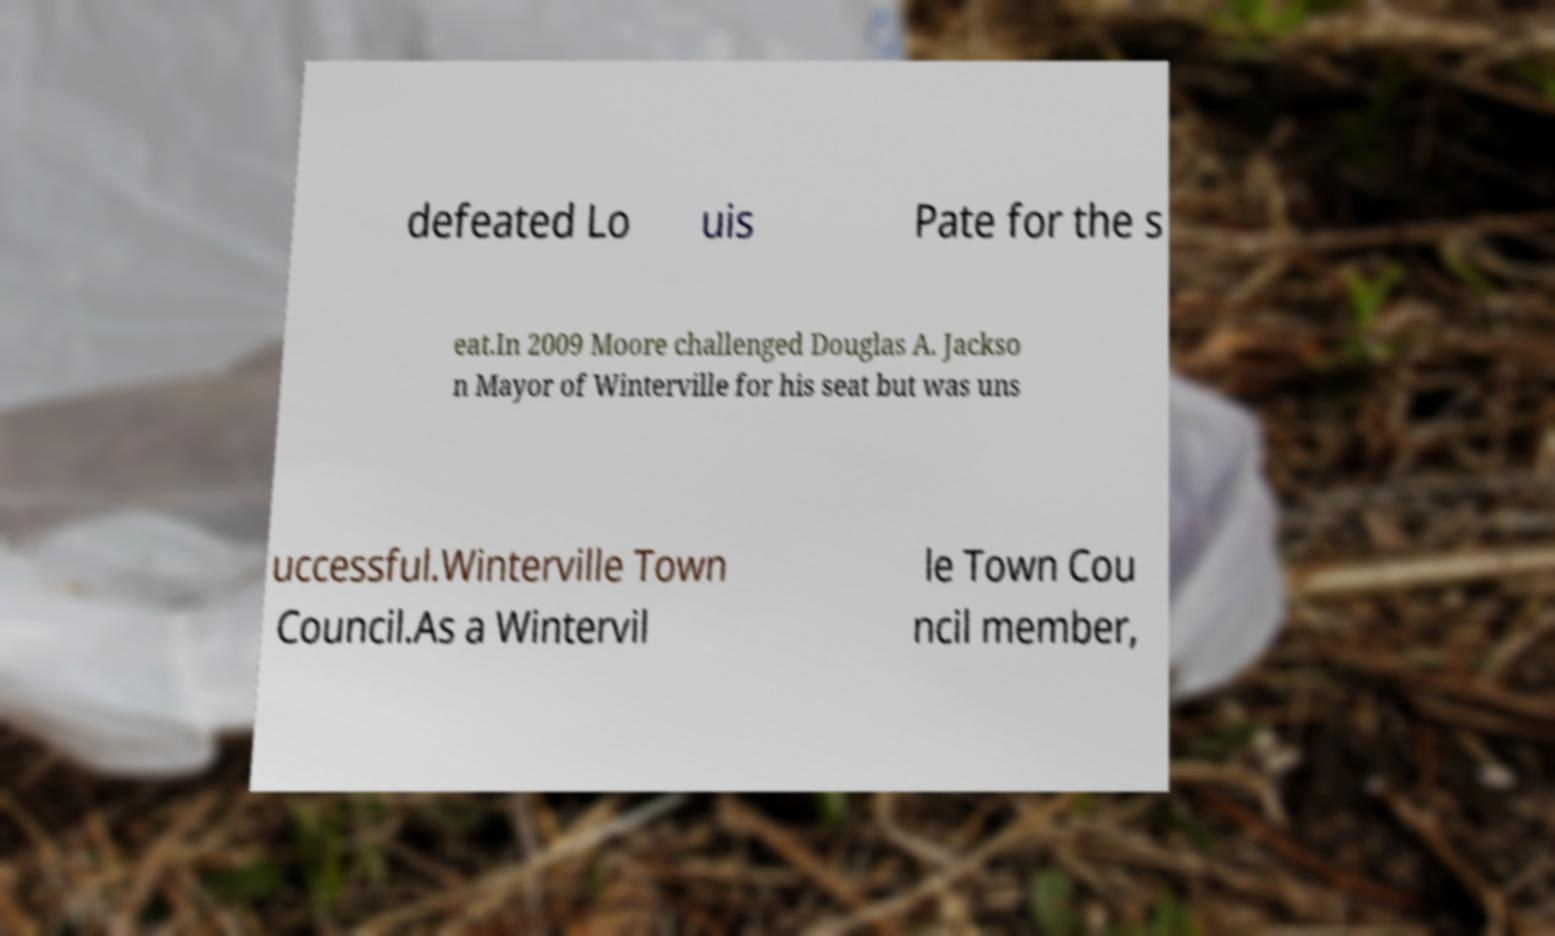For documentation purposes, I need the text within this image transcribed. Could you provide that? defeated Lo uis Pate for the s eat.In 2009 Moore challenged Douglas A. Jackso n Mayor of Winterville for his seat but was uns uccessful.Winterville Town Council.As a Wintervil le Town Cou ncil member, 